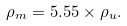Convert formula to latex. <formula><loc_0><loc_0><loc_500><loc_500>\rho _ { m } = 5 . 5 5 \times \rho _ { u } .</formula> 